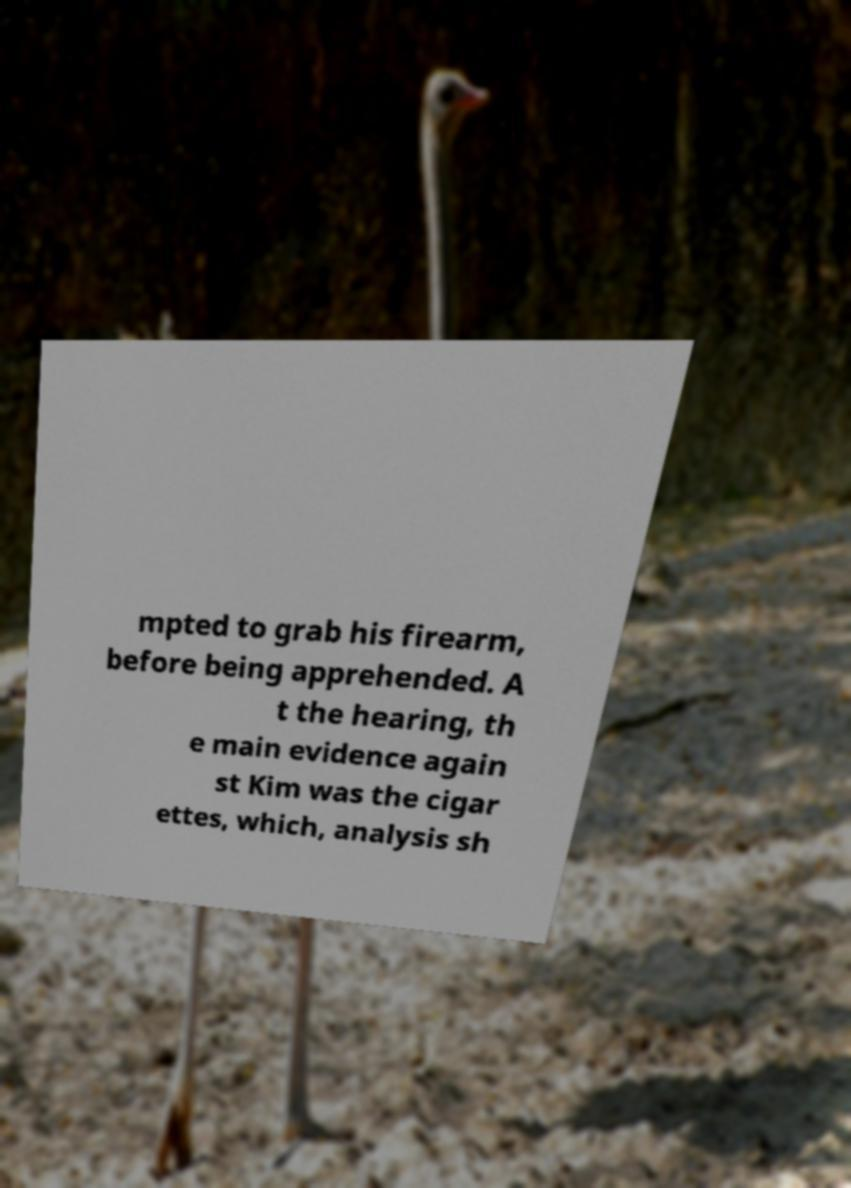For documentation purposes, I need the text within this image transcribed. Could you provide that? mpted to grab his firearm, before being apprehended. A t the hearing, th e main evidence again st Kim was the cigar ettes, which, analysis sh 